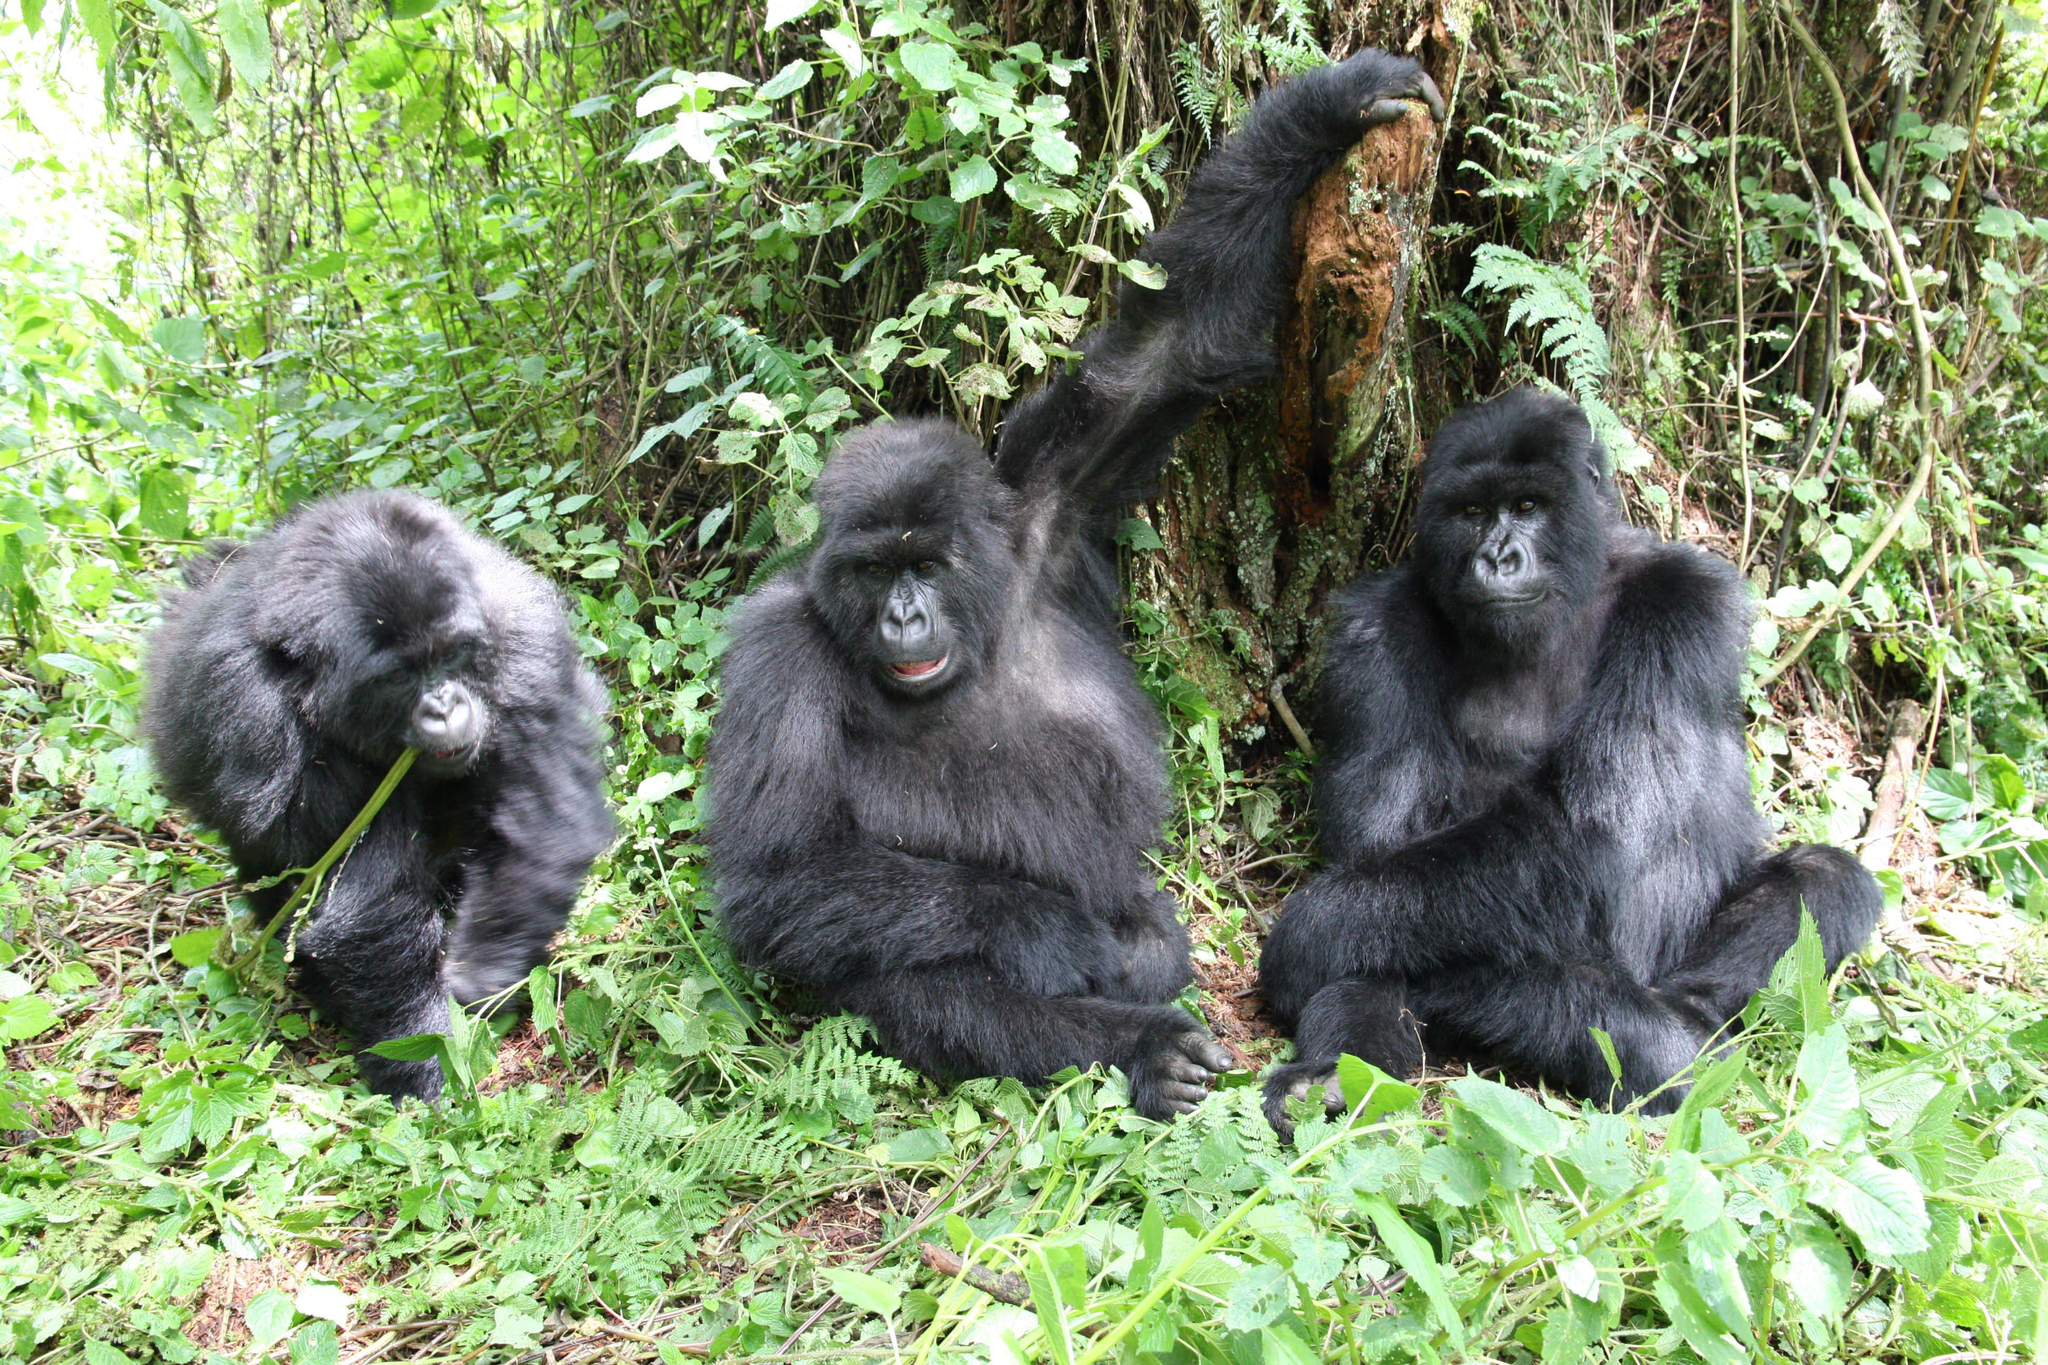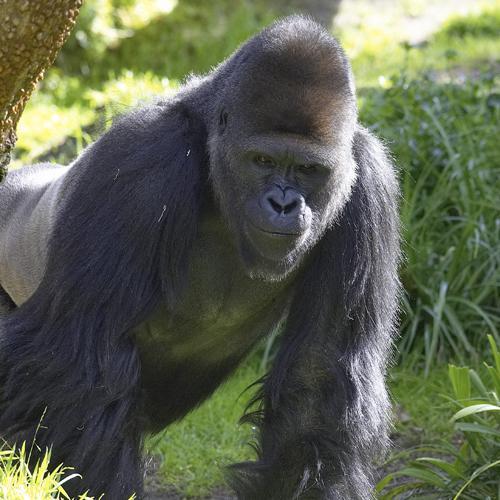The first image is the image on the left, the second image is the image on the right. For the images displayed, is the sentence "There is a gorilla holding another gorilla from the back in one of the images." factually correct? Answer yes or no. No. The first image is the image on the left, the second image is the image on the right. For the images shown, is this caption "At least one image contains a single adult male gorilla, who is walking in a bent over pose and eyeing the camera." true? Answer yes or no. Yes. The first image is the image on the left, the second image is the image on the right. For the images shown, is this caption "The left image contains exactly two gorillas." true? Answer yes or no. No. The first image is the image on the left, the second image is the image on the right. Examine the images to the left and right. Is the description "There are exactly three animals outside." accurate? Answer yes or no. No. 